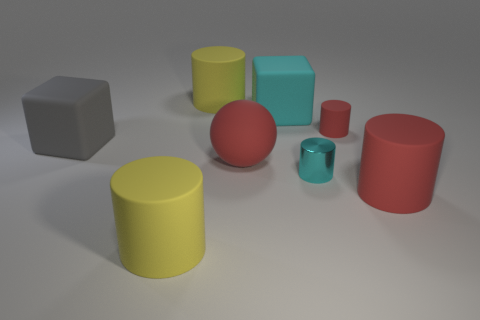What material is the large cube that is the same color as the small shiny thing?
Your answer should be very brief. Rubber. There is a cyan object that is the same size as the ball; what is its material?
Ensure brevity in your answer.  Rubber. There is a red rubber thing that is the same size as the cyan metal cylinder; what shape is it?
Your answer should be compact. Cylinder. What number of other things are the same color as the tiny matte cylinder?
Ensure brevity in your answer.  2. There is a red object that is behind the gray rubber thing; is it the same shape as the large yellow object that is in front of the gray cube?
Offer a very short reply. Yes. What number of things are either large cylinders that are to the left of the small red thing or gray rubber cubes that are behind the cyan cylinder?
Ensure brevity in your answer.  3. How many other objects are there of the same material as the big cyan block?
Give a very brief answer. 6. Does the red cylinder in front of the large red matte ball have the same material as the tiny red thing?
Your response must be concise. Yes. Are there more tiny metallic objects behind the small rubber thing than big yellow cylinders that are in front of the big cyan thing?
Your answer should be compact. No. How many objects are big red rubber things in front of the tiny red rubber cylinder or big matte cylinders?
Provide a short and direct response. 4. 